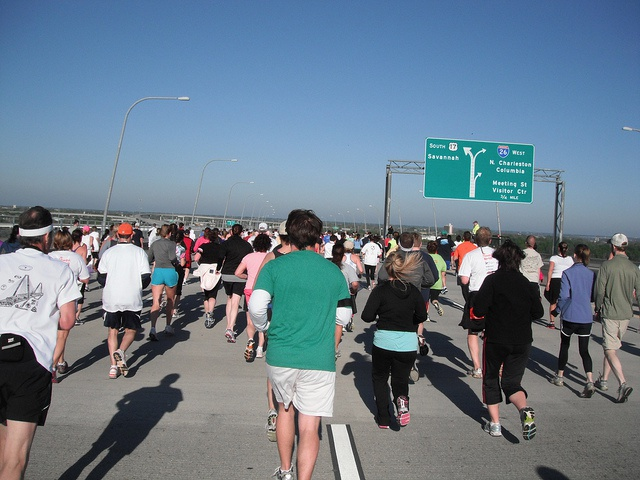Describe the objects in this image and their specific colors. I can see people in blue, black, gray, darkgray, and lightgray tones, people in blue, teal, lightgray, and black tones, people in blue, lightgray, black, darkgray, and gray tones, people in blue, black, gray, darkgray, and salmon tones, and people in blue, black, lightblue, gray, and darkgray tones in this image. 